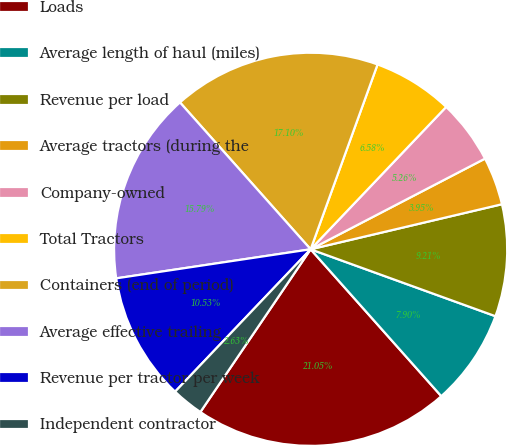Convert chart to OTSL. <chart><loc_0><loc_0><loc_500><loc_500><pie_chart><fcel>Loads<fcel>Average length of haul (miles)<fcel>Revenue per load<fcel>Average tractors (during the<fcel>Company-owned<fcel>Total Tractors<fcel>Containers (end of period)<fcel>Average effective trailing<fcel>Revenue per tractor per week<fcel>Independent contractor<nl><fcel>21.05%<fcel>7.9%<fcel>9.21%<fcel>3.95%<fcel>5.26%<fcel>6.58%<fcel>17.1%<fcel>15.79%<fcel>10.53%<fcel>2.63%<nl></chart> 